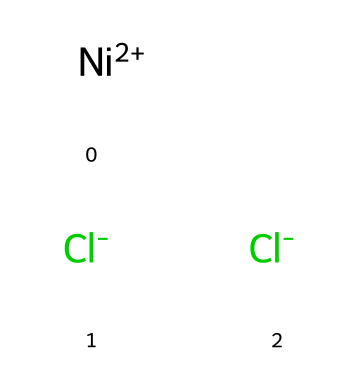What is the oxidation state of nickel in this compound? The notation [Ni+2] indicates that nickel has a +2 charge; therefore, its oxidation state is +2.
Answer: +2 How many chloride ions are present in the complex? The structure shows two [Cl-] ions, indicating that there are two chloride ions associated with the nickel in this compound.
Answer: 2 What type of coordination compound is formed by nickel(II) chloride? Nickel(II) chloride is a coordination compound because it consists of a central metal ion (nickel) surrounded by ligands (chloride ions).
Answer: coordination compound What is the total number of atoms in this compound? The structure shows one nickel atom and two chlorine atoms, leading to a total of three atoms in the entire compound.
Answer: 3 What type of bonding occurs between nickel and chloride ions? The bonding between nickel and chloride ions is ionic, as indicated by the charge separation between the +2 nickel cation and the -1 chloride anions.
Answer: ionic How does the molecular arrangement affect its use in electroplating? The arrangement allows for effective electrochemical reactions since the ionic nature facilitates the transfer of electrons during the electroplating process.
Answer: effective electrochemical reactions What property of nickel(II) chloride makes it suitable for electroplating? Nickel(II) chloride is soluble in water, which allows it to dissociate into ions, facilitating the electroplating process through an aqueous solution.
Answer: soluble in water 